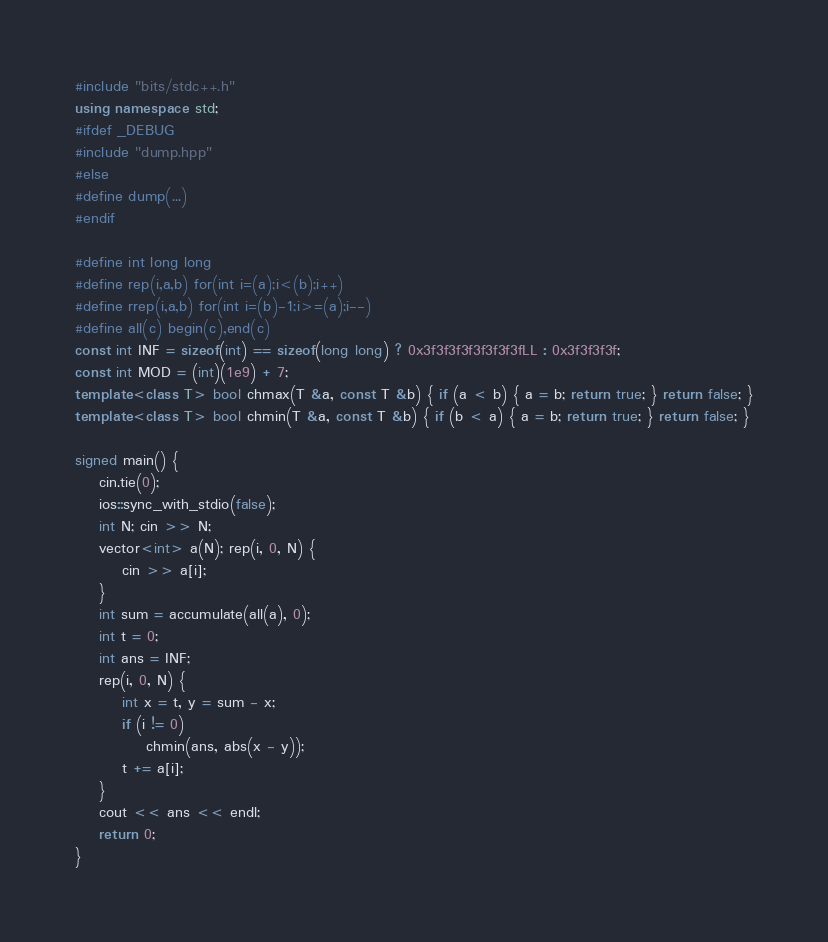Convert code to text. <code><loc_0><loc_0><loc_500><loc_500><_C++_>#include "bits/stdc++.h"
using namespace std;
#ifdef _DEBUG
#include "dump.hpp"
#else
#define dump(...)
#endif

#define int long long
#define rep(i,a,b) for(int i=(a);i<(b);i++)
#define rrep(i,a,b) for(int i=(b)-1;i>=(a);i--)
#define all(c) begin(c),end(c)
const int INF = sizeof(int) == sizeof(long long) ? 0x3f3f3f3f3f3f3f3fLL : 0x3f3f3f3f;
const int MOD = (int)(1e9) + 7;
template<class T> bool chmax(T &a, const T &b) { if (a < b) { a = b; return true; } return false; }
template<class T> bool chmin(T &a, const T &b) { if (b < a) { a = b; return true; } return false; }

signed main() {
	cin.tie(0);
	ios::sync_with_stdio(false);
	int N; cin >> N;
	vector<int> a(N); rep(i, 0, N) {
		cin >> a[i];
	}
	int sum = accumulate(all(a), 0);
	int t = 0;
	int ans = INF;
	rep(i, 0, N) {
		int x = t, y = sum - x;
		if (i != 0)
			chmin(ans, abs(x - y));
		t += a[i];
	}
	cout << ans << endl;
	return 0;
}</code> 